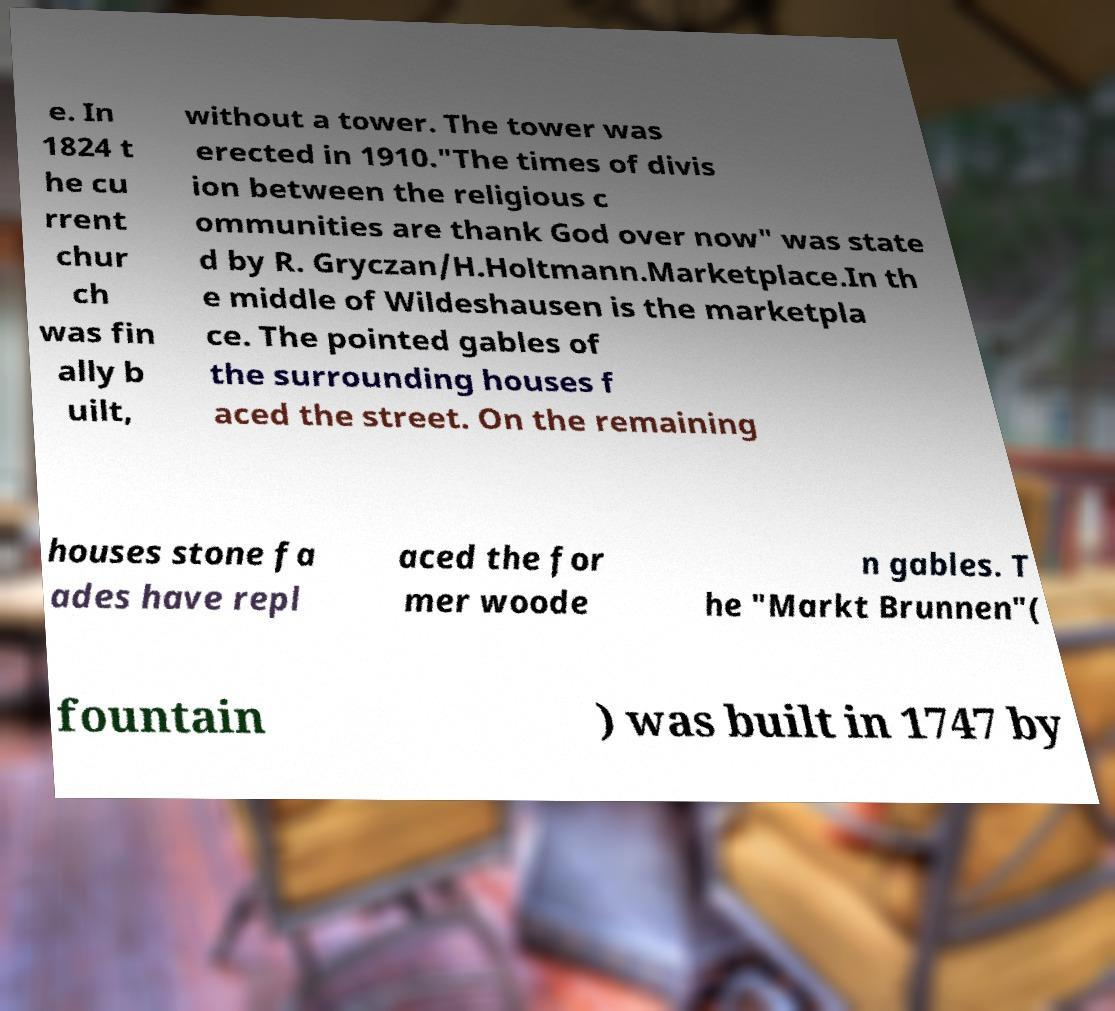Please read and relay the text visible in this image. What does it say? e. In 1824 t he cu rrent chur ch was fin ally b uilt, without a tower. The tower was erected in 1910."The times of divis ion between the religious c ommunities are thank God over now" was state d by R. Gryczan/H.Holtmann.Marketplace.In th e middle of Wildeshausen is the marketpla ce. The pointed gables of the surrounding houses f aced the street. On the remaining houses stone fa ades have repl aced the for mer woode n gables. T he "Markt Brunnen"( fountain ) was built in 1747 by 